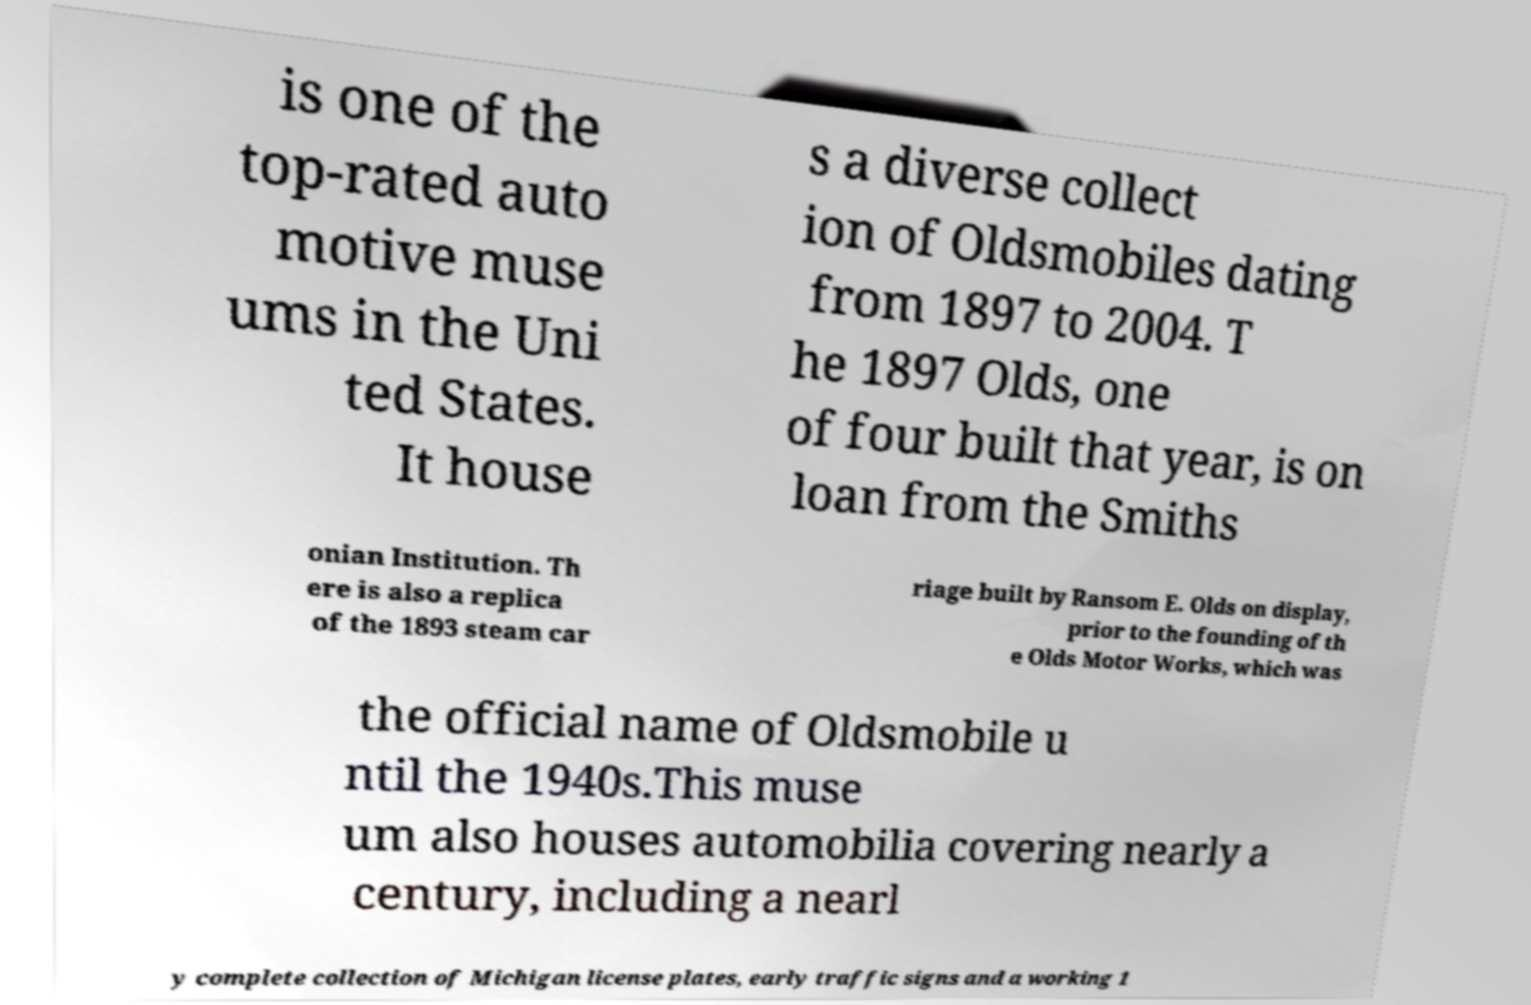Could you extract and type out the text from this image? is one of the top-rated auto motive muse ums in the Uni ted States. It house s a diverse collect ion of Oldsmobiles dating from 1897 to 2004. T he 1897 Olds, one of four built that year, is on loan from the Smiths onian Institution. Th ere is also a replica of the 1893 steam car riage built by Ransom E. Olds on display, prior to the founding of th e Olds Motor Works, which was the official name of Oldsmobile u ntil the 1940s.This muse um also houses automobilia covering nearly a century, including a nearl y complete collection of Michigan license plates, early traffic signs and a working 1 